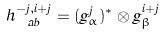<formula> <loc_0><loc_0><loc_500><loc_500>h ^ { - j , i + j } _ { \ a b } = ( g ^ { j } _ { \alpha } ) ^ { * } \otimes g ^ { i + j } _ { \beta }</formula> 